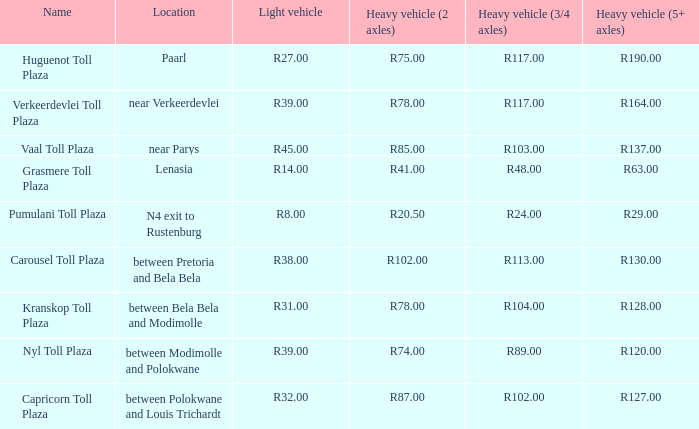00? R32.00. Parse the full table. {'header': ['Name', 'Location', 'Light vehicle', 'Heavy vehicle (2 axles)', 'Heavy vehicle (3/4 axles)', 'Heavy vehicle (5+ axles)'], 'rows': [['Huguenot Toll Plaza', 'Paarl', 'R27.00', 'R75.00', 'R117.00', 'R190.00'], ['Verkeerdevlei Toll Plaza', 'near Verkeerdevlei', 'R39.00', 'R78.00', 'R117.00', 'R164.00'], ['Vaal Toll Plaza', 'near Parys', 'R45.00', 'R85.00', 'R103.00', 'R137.00'], ['Grasmere Toll Plaza', 'Lenasia', 'R14.00', 'R41.00', 'R48.00', 'R63.00'], ['Pumulani Toll Plaza', 'N4 exit to Rustenburg', 'R8.00', 'R20.50', 'R24.00', 'R29.00'], ['Carousel Toll Plaza', 'between Pretoria and Bela Bela', 'R38.00', 'R102.00', 'R113.00', 'R130.00'], ['Kranskop Toll Plaza', 'between Bela Bela and Modimolle', 'R31.00', 'R78.00', 'R104.00', 'R128.00'], ['Nyl Toll Plaza', 'between Modimolle and Polokwane', 'R39.00', 'R74.00', 'R89.00', 'R120.00'], ['Capricorn Toll Plaza', 'between Polokwane and Louis Trichardt', 'R32.00', 'R87.00', 'R102.00', 'R127.00']]} 